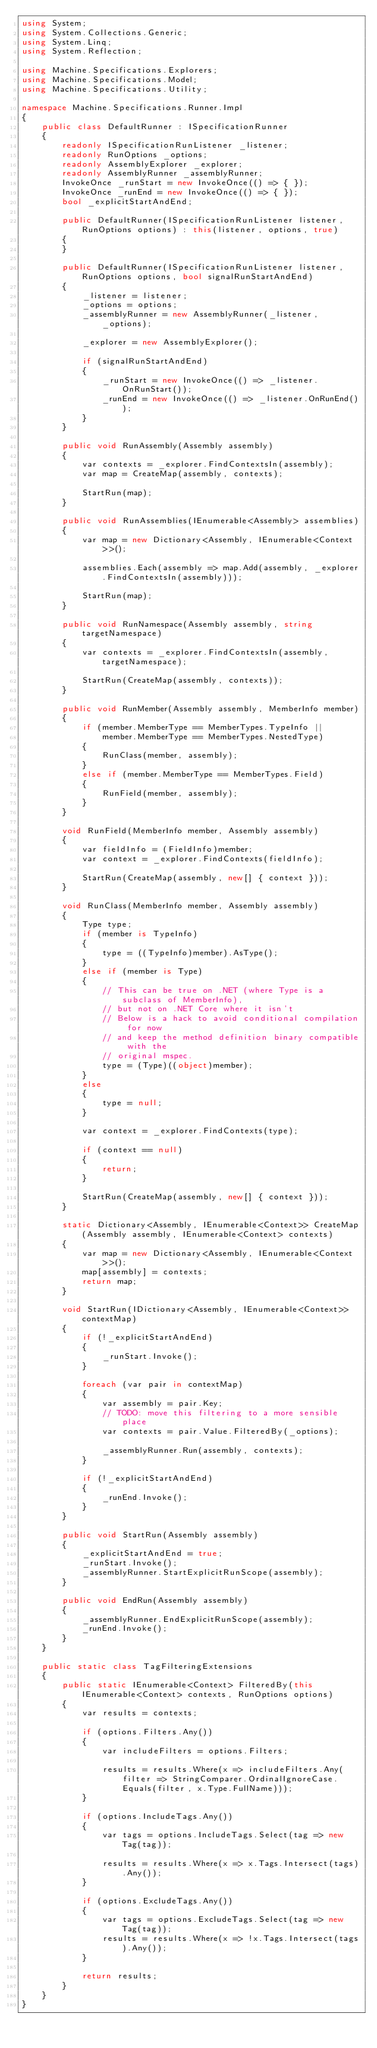<code> <loc_0><loc_0><loc_500><loc_500><_C#_>using System;
using System.Collections.Generic;
using System.Linq;
using System.Reflection;

using Machine.Specifications.Explorers;
using Machine.Specifications.Model;
using Machine.Specifications.Utility;

namespace Machine.Specifications.Runner.Impl
{
    public class DefaultRunner : ISpecificationRunner
    {
        readonly ISpecificationRunListener _listener;
        readonly RunOptions _options;
        readonly AssemblyExplorer _explorer;
        readonly AssemblyRunner _assemblyRunner;
        InvokeOnce _runStart = new InvokeOnce(() => { });
        InvokeOnce _runEnd = new InvokeOnce(() => { });
        bool _explicitStartAndEnd;

        public DefaultRunner(ISpecificationRunListener listener, RunOptions options) : this(listener, options, true)
        {
        }

        public DefaultRunner(ISpecificationRunListener listener, RunOptions options, bool signalRunStartAndEnd)
        {
            _listener = listener;
            _options = options;
            _assemblyRunner = new AssemblyRunner(_listener, _options);

            _explorer = new AssemblyExplorer();

            if (signalRunStartAndEnd)
            {
                _runStart = new InvokeOnce(() => _listener.OnRunStart());
                _runEnd = new InvokeOnce(() => _listener.OnRunEnd());
            }
        }

        public void RunAssembly(Assembly assembly)
        {
            var contexts = _explorer.FindContextsIn(assembly);
            var map = CreateMap(assembly, contexts);

            StartRun(map);
        }

        public void RunAssemblies(IEnumerable<Assembly> assemblies)
        {
            var map = new Dictionary<Assembly, IEnumerable<Context>>();

            assemblies.Each(assembly => map.Add(assembly, _explorer.FindContextsIn(assembly)));

            StartRun(map);
        }

        public void RunNamespace(Assembly assembly, string targetNamespace)
        {
            var contexts = _explorer.FindContextsIn(assembly, targetNamespace);

            StartRun(CreateMap(assembly, contexts));
        }

        public void RunMember(Assembly assembly, MemberInfo member)
        {
            if (member.MemberType == MemberTypes.TypeInfo ||
                member.MemberType == MemberTypes.NestedType)
            {
                RunClass(member, assembly);
            }
            else if (member.MemberType == MemberTypes.Field)
            {
                RunField(member, assembly);
            }
        }

        void RunField(MemberInfo member, Assembly assembly)
        {
            var fieldInfo = (FieldInfo)member;
            var context = _explorer.FindContexts(fieldInfo);

            StartRun(CreateMap(assembly, new[] { context }));
        }

        void RunClass(MemberInfo member, Assembly assembly)
        {
            Type type;
            if (member is TypeInfo)
            {
                type = ((TypeInfo)member).AsType();
            }
            else if (member is Type)
            {
                // This can be true on .NET (where Type is a subclass of MemberInfo),
                // but not on .NET Core where it isn't
                // Below is a hack to avoid conditional compilation for now
                // and keep the method definition binary compatible with the
                // original mspec.
                type = (Type)((object)member);
            }
            else
            {
                type = null;
            }

            var context = _explorer.FindContexts(type);

            if (context == null)
            {
                return;
            }

            StartRun(CreateMap(assembly, new[] { context }));
        }

        static Dictionary<Assembly, IEnumerable<Context>> CreateMap(Assembly assembly, IEnumerable<Context> contexts)
        {
            var map = new Dictionary<Assembly, IEnumerable<Context>>();
            map[assembly] = contexts;
            return map;
        }

        void StartRun(IDictionary<Assembly, IEnumerable<Context>> contextMap)
        {
            if (!_explicitStartAndEnd)
            {
                _runStart.Invoke();
            }

            foreach (var pair in contextMap)
            {
                var assembly = pair.Key;
                // TODO: move this filtering to a more sensible place
                var contexts = pair.Value.FilteredBy(_options);

                _assemblyRunner.Run(assembly, contexts);
            }

            if (!_explicitStartAndEnd)
            {
                _runEnd.Invoke();
            }
        }

        public void StartRun(Assembly assembly)
        {
            _explicitStartAndEnd = true;
            _runStart.Invoke();
            _assemblyRunner.StartExplicitRunScope(assembly);
        }

        public void EndRun(Assembly assembly)
        {
            _assemblyRunner.EndExplicitRunScope(assembly);
            _runEnd.Invoke();
        }
    }

    public static class TagFilteringExtensions
    {
        public static IEnumerable<Context> FilteredBy(this IEnumerable<Context> contexts, RunOptions options)
        {
            var results = contexts;

            if (options.Filters.Any())
            {
                var includeFilters = options.Filters;

                results = results.Where(x => includeFilters.Any(filter => StringComparer.OrdinalIgnoreCase.Equals(filter, x.Type.FullName)));
            }

            if (options.IncludeTags.Any())
            {
                var tags = options.IncludeTags.Select(tag => new Tag(tag));

                results = results.Where(x => x.Tags.Intersect(tags).Any());
            }

            if (options.ExcludeTags.Any())
            {
                var tags = options.ExcludeTags.Select(tag => new Tag(tag));
                results = results.Where(x => !x.Tags.Intersect(tags).Any());
            }

            return results;
        }
    }
}</code> 